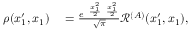<formula> <loc_0><loc_0><loc_500><loc_500>\begin{array} { r l } { \rho ( x _ { 1 } ^ { \prime } , x _ { 1 } ) } & = \frac { e ^ { - \frac { x _ { 1 } ^ { 2 } } { 2 } - \frac { x _ { 1 } ^ { 2 } } { 2 } } } { \sqrt { \pi } } \mathcal { R } ^ { ( A ) } ( x _ { 1 } ^ { \prime } , x _ { 1 } ) , } \end{array}</formula> 